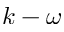<formula> <loc_0><loc_0><loc_500><loc_500>k - \omega</formula> 